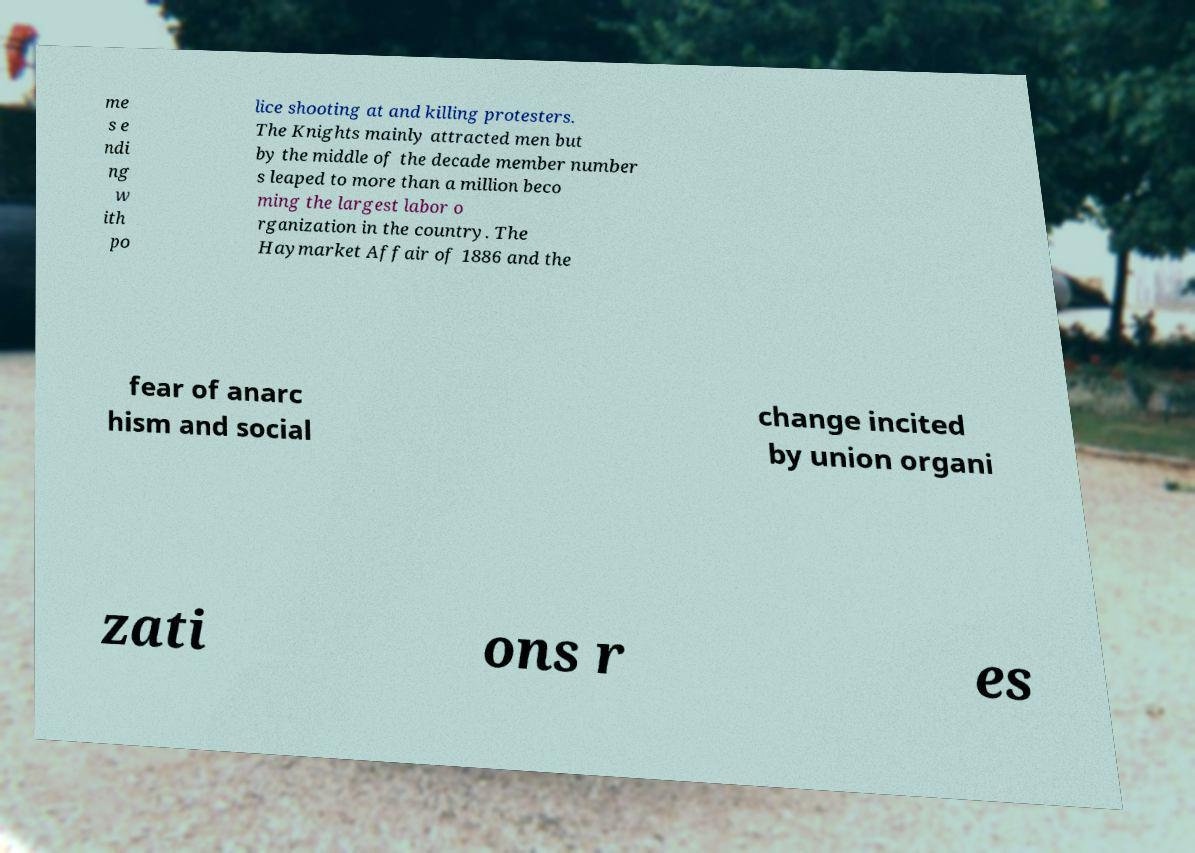Can you read and provide the text displayed in the image?This photo seems to have some interesting text. Can you extract and type it out for me? me s e ndi ng w ith po lice shooting at and killing protesters. The Knights mainly attracted men but by the middle of the decade member number s leaped to more than a million beco ming the largest labor o rganization in the country. The Haymarket Affair of 1886 and the fear of anarc hism and social change incited by union organi zati ons r es 